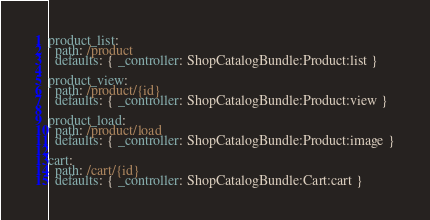<code> <loc_0><loc_0><loc_500><loc_500><_YAML_>product_list:
  path: /product
  defaults: { _controller: ShopCatalogBundle:Product:list }

product_view:
  path: /product/{id}
  defaults: { _controller: ShopCatalogBundle:Product:view }

product_load:
  path: /product/load
  defaults: { _controller: ShopCatalogBundle:Product:image }

cart:
  path: /cart/{id}
  defaults: { _controller: ShopCatalogBundle:Cart:cart }</code> 